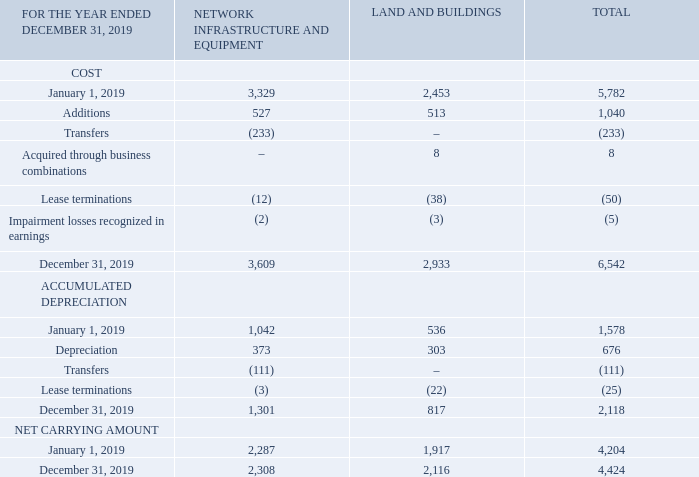Note 15 Leases
RIGHT-OF-USE ASSETS
BCE’s significant right-of-use assets under leases are satellites, office premises, land, cellular tower sites, retail outlets and OOH advertising spaces. Right-of-use assets are presented in Property, plant and equipment in the statement of financial position.
What are BCE's significant right-of-use assets under leases? Satellites, office premises, land, cellular tower sites, retail outlets and ooh advertising spaces. Where are the right-of-use assets presented? Presented in property, plant and equipment in the statement of financial position. What is the total net carrying amount on December 31, 2019? 4,424. What is the percentage of total additions over the total costs of the right-of-use assets?
Answer scale should be: percent. 1,040/6,542
Answer: 15.9. What is the change in the total net carrying amount in 2019? 4,424-4,204
Answer: 220. What is the change in the total accumulated depreciation in 2019? 2,118-1,578
Answer: 540. 